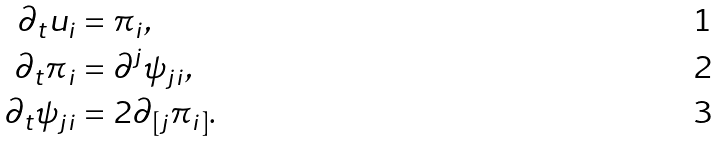Convert formula to latex. <formula><loc_0><loc_0><loc_500><loc_500>\partial _ { t } u _ { i } & = \pi _ { i } , \\ \partial _ { t } \pi _ { i } & = \partial ^ { j } \psi _ { j i } , \\ \partial _ { t } \psi _ { j i } & = 2 \partial _ { [ j } \pi _ { i ] } .</formula> 